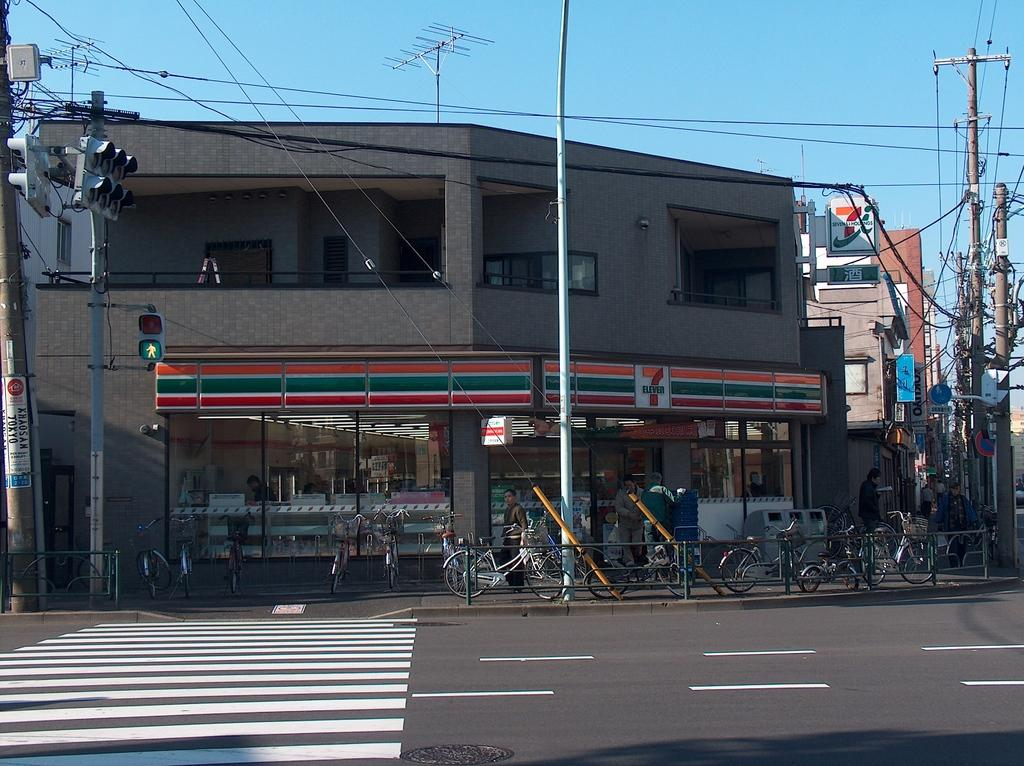<image>
Render a clear and concise summary of the photo. One must cross the crossing to get to the 7 eleven. 